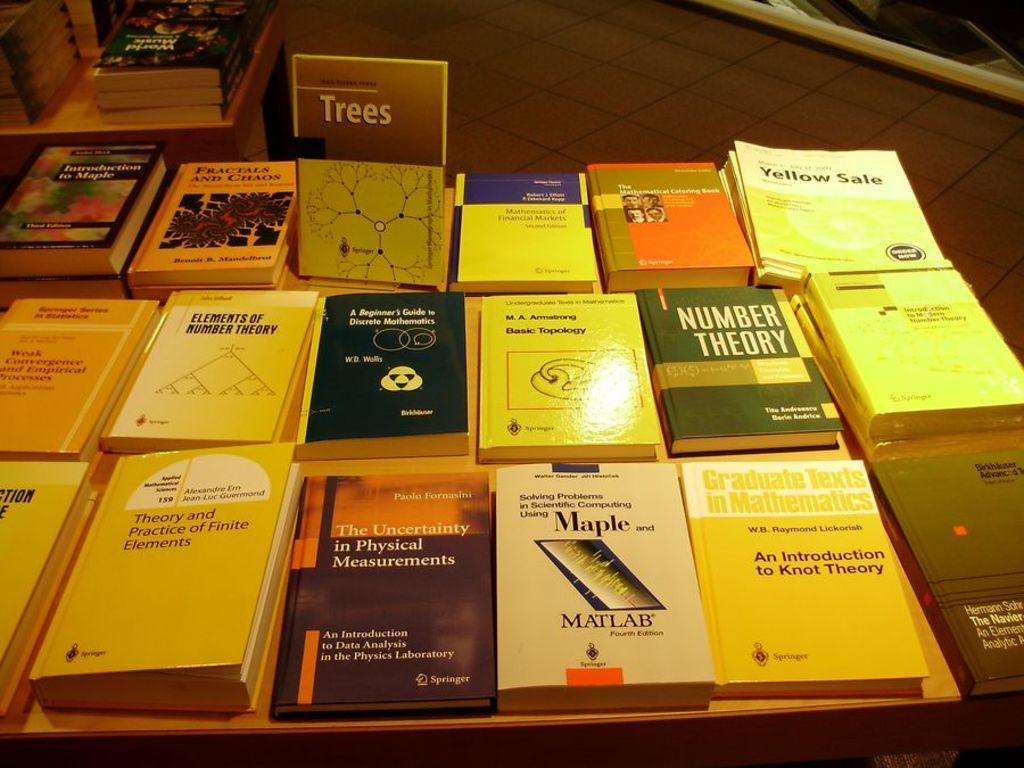What is the main object in the image? There is a table in the image. What is placed on the table? There are books placed on the table. What color of paint is used to cover the books in the image? There is no paint or any indication of paint on the books in the image. 